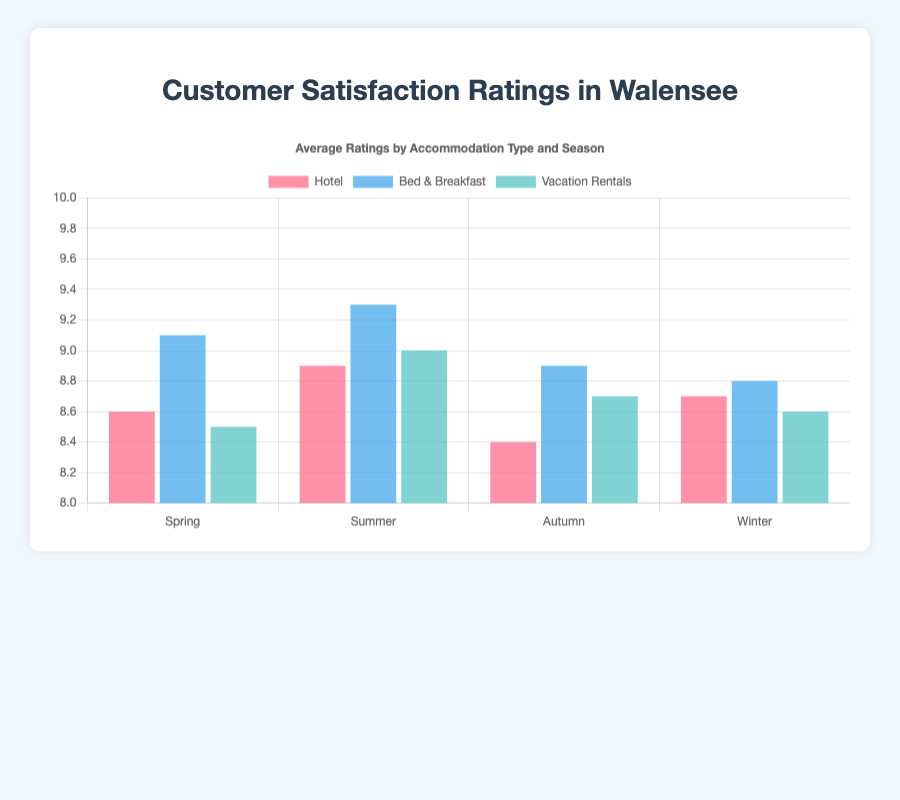Which type of accommodation received the highest rating in autumn? Compare the bars for autumn and identify the highest value. Bed & Breakfast has a rating of 8.9, Hotel has 8.4, and Vacation Rentals has 8.7.
Answer: Bed & Breakfast Which season did hotels receive the lowest rating? Compare the bars for all seasons under Hotel. The lowest is 8.4 in autumn.
Answer: Autumn What is the difference in average ratings between the best and worst seasons for Bed & Breakfast? Identify the highest rating (9.3 in summer) and the lowest rating (8.8 in winter) for Bed & Breakfast. The difference is 9.3 - 8.8 = 0.5.
Answer: 0.5 Which season has the highest overall average satisfaction rating? Identify the highest rating across all seasons and types of accommodation. Bed & Breakfast in summer has the highest rating of 9.3.
Answer: Summer Is there any season where all types of accommodation ratings are above 8.5? Check each season and see if all accommodation types have ratings above 8.5. Spring has Hotel (8.6), Bed & Breakfast (9.1), and Vacation Rentals (8.5).
Answer: Spring What is the overall average rating for vacation rentals? Sum the 4 ratings for Vacation Rentals and divide by 4. (8.5 + 9.0 + 8.7 + 8.6) / 4 = 8.7
Answer: 8.7 Which type of accommodation has the smallest variation in ratings across seasons? Calculate the range (highest - lowest) for each accommodation type, Hotel: 8.9 - 8.4 = 0.5, Bed & Breakfast: 9.3 - 8.8 = 0.5, Vacation Rentals: 9.0 - 8.5 = 0.5. All variations are equal (0.5).
Answer: All How much higher is the average rating for Bed & Breakfast in summer compared to hotels in summer? Subtract Hotel's summer rating from Bed & Breakfast's summer rating. 9.3 - 8.9 = 0.4.
Answer: 0.4 